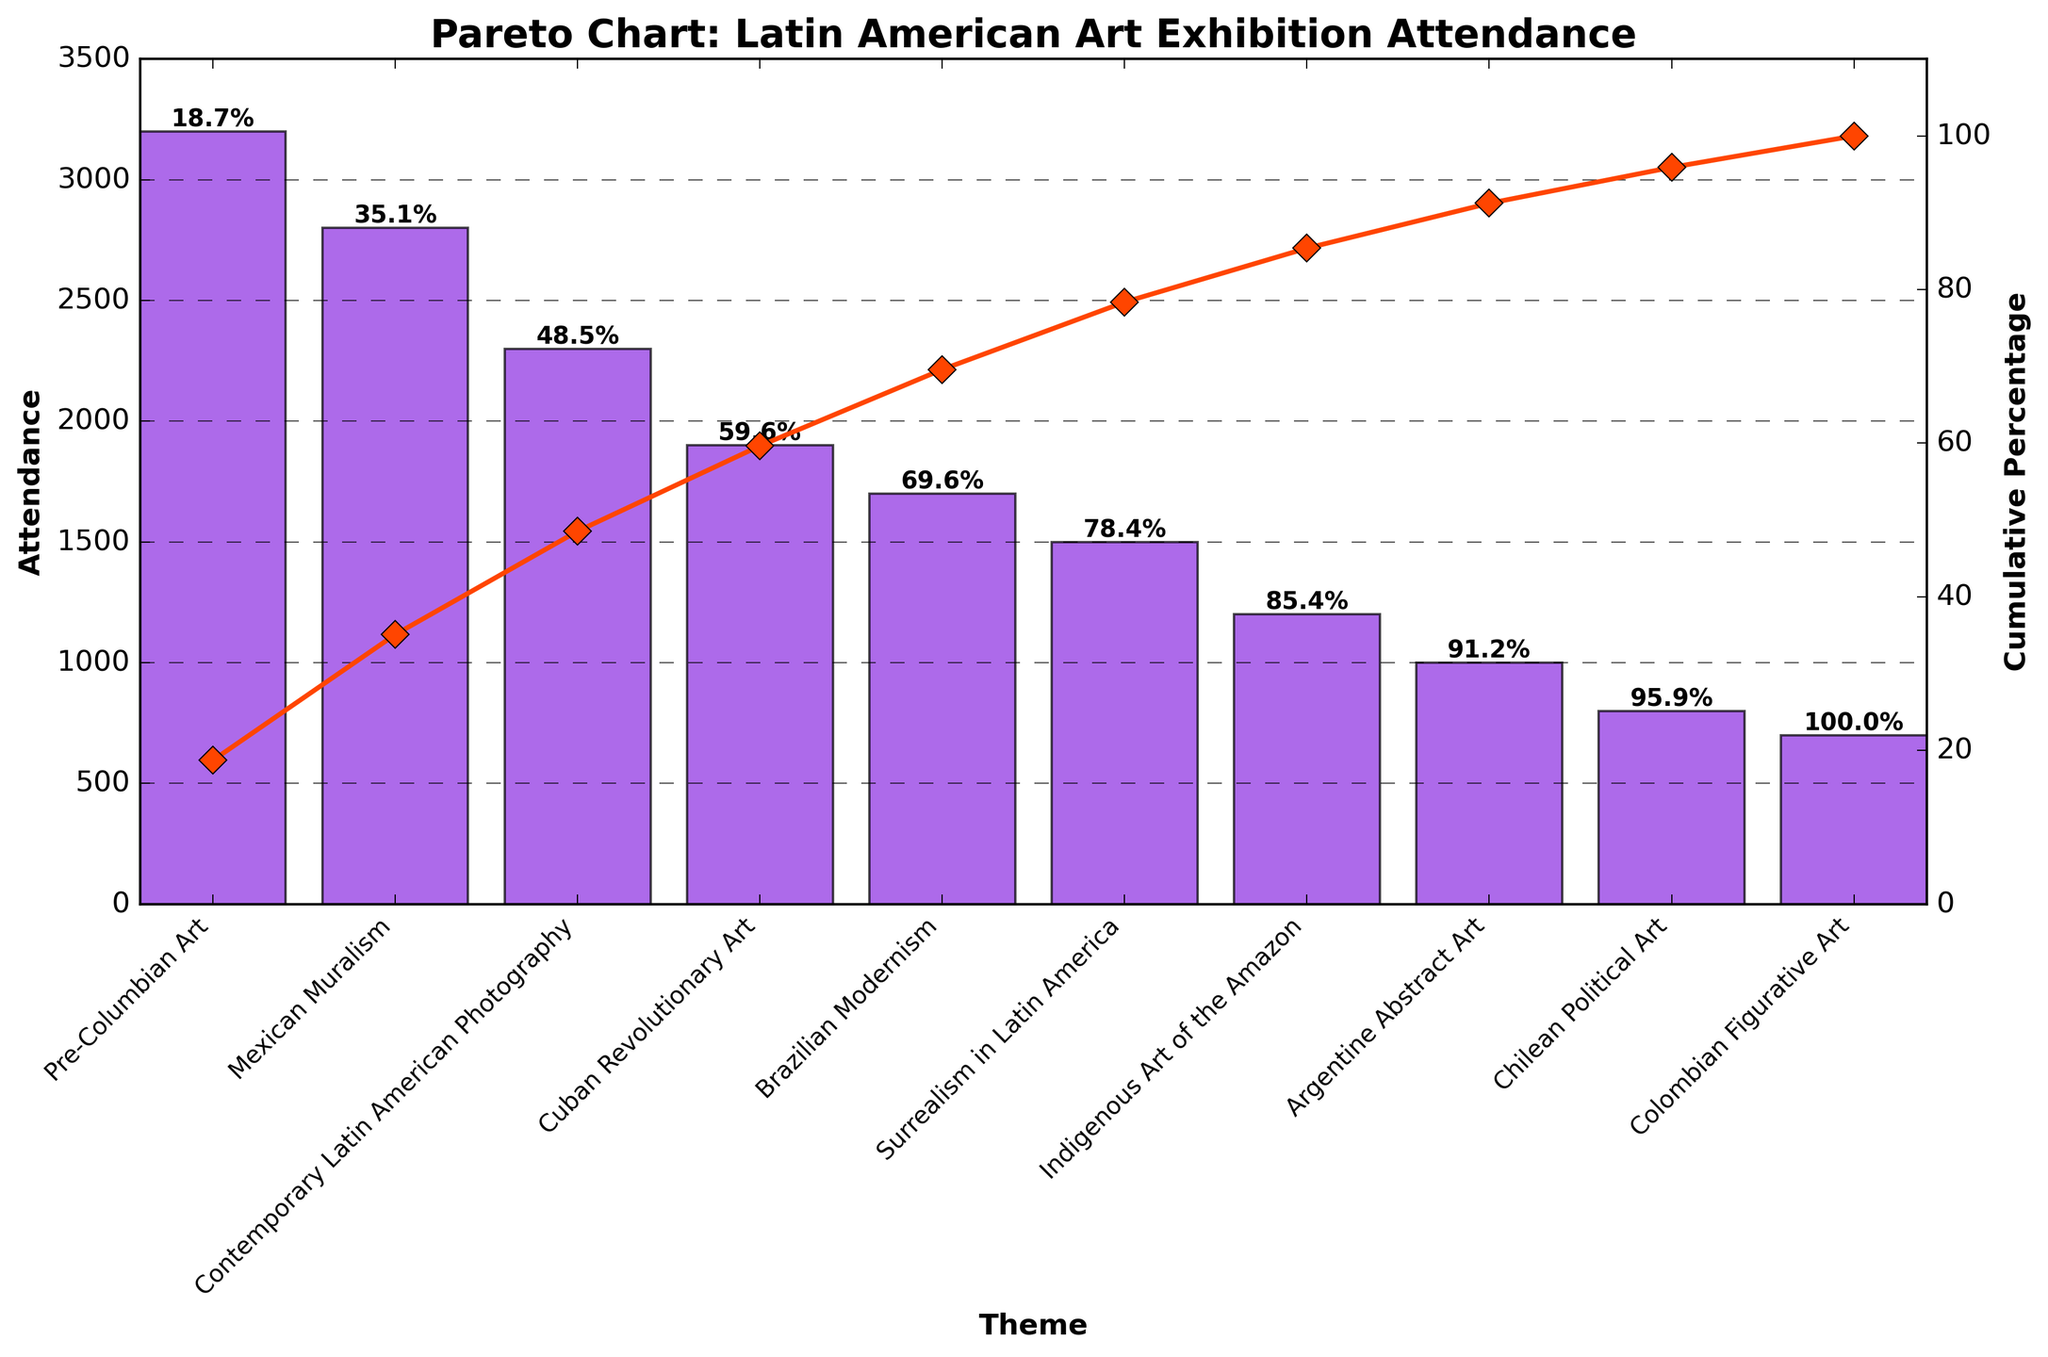What is the title of the Pareto chart? The title of the Pareto chart is displayed prominently at the top of the figure.
Answer: Pareto Chart: Latin American Art Exhibition Attendance How many themes are categorized in the chart? By counting the number of bars, we can see there are 10 themes categorized in the chart.
Answer: 10 Which theme has the highest attendance? The tallest bar represents the theme with the highest attendance.
Answer: Pre-Columbian Art Which theme has the lowest attendance? The shortest bar represents the theme with the lowest attendance.
Answer: Colombian Figurative Art What is the cumulative percentage for the Mexican Muralism theme? Locate the bar for Mexican Muralism and read the cumulative percentage label above it.
Answer: 48.7% What is the total attendance for Pre-Columbian Art and Mexican Muralism combined? Add the attendance figures for Pre-Columbian Art (3200) and Mexican Muralism (2800). 3200 + 2800 = 6000
Answer: 6000 How does the attendance for Surrealism in Latin America compare with that of Brazilian Modernism? Compare the heights of the bars for Surrealism in Latin America and Brazilian Modernism. Surrealism in Latin America has 1500 and Brazilian Modernism has 1700. Brazilian Modernism is higher.
Answer: Brazilian Modernism is higher What is the added attendance of the bottom three themes? Sum the attendance figures for Indigenous Art of the Amazon (1200), Argentine Abstract Art (1000), and Chilean Political Art (800). 1200 + 1000 + 800 = 3000
Answer: 3000 At what cumulative percentage do the top three themes in attendance reach? Sum up the cumulative percentages of Pre-Columbian Art, Mexican Muralism, and Contemporary Latin American Photography from the labels. 23.6% + 48.7% + 65.6% = 65.6%
Answer: 65.6% What color are the bars in the chart? The bars are depicted in a solid color, which is visually identifiable.
Answer: Purple What is indicated by the line with diamond markers in the chart? The line with diamond markers represents the cumulative percentage of attendance as various themes are accumulated.
Answer: Cumulative Percentage 